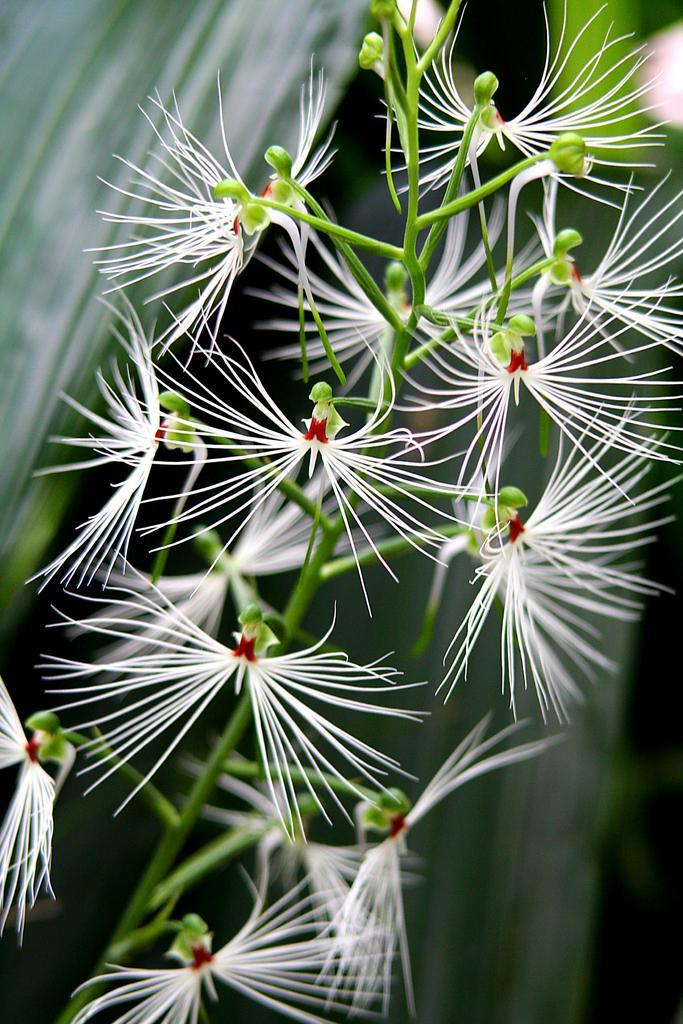Please provide a concise description of this image. In this picture we can see few flowers and blurry background. 